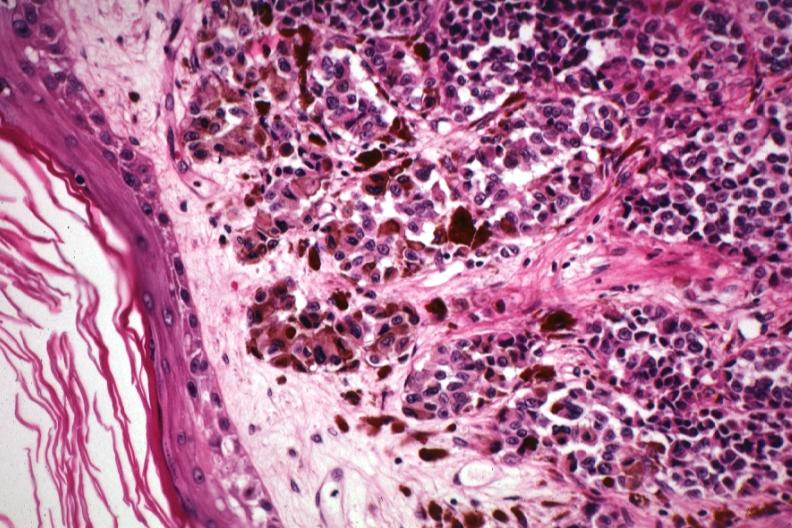s malignant melanoma present?
Answer the question using a single word or phrase. Yes 